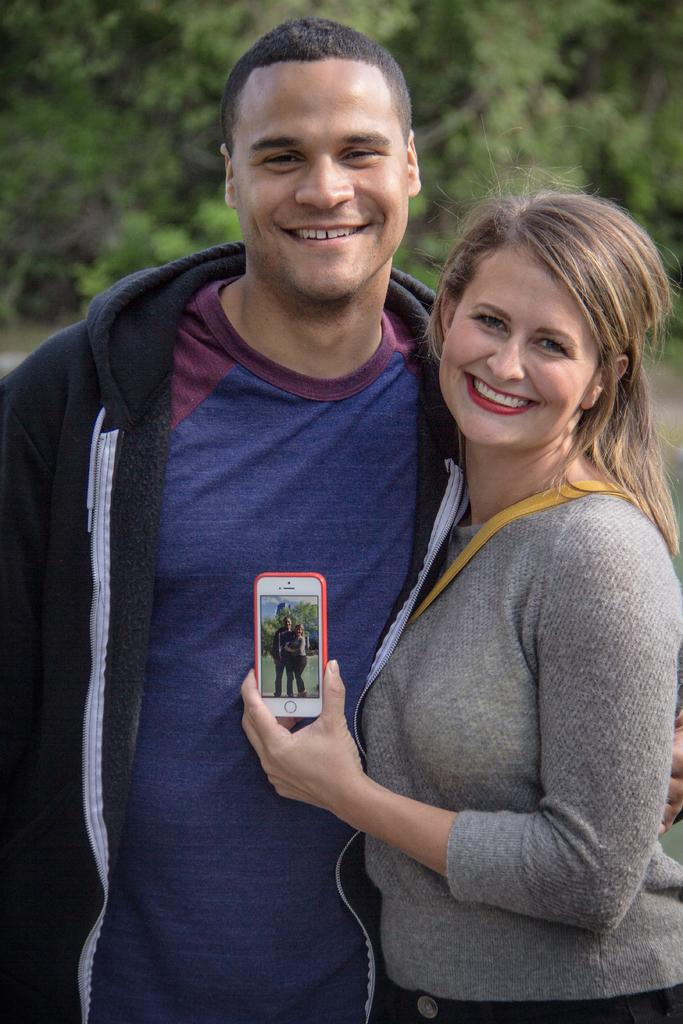How many people are in the image? There are two people in the image, a man and a woman. What are the man and woman doing in the image? Both the man and woman are standing and smiling. What is the woman holding in her left hand? The woman is holding a mobile in her left hand. What can be seen in the background of the image? There are trees in the background of the image. What type of planes can be seen flying in the image? There are no planes visible in the image. Who is the manager of the actors in the image? There are no actors or managers present in the image; it features a man and a woman standing and smiling. 